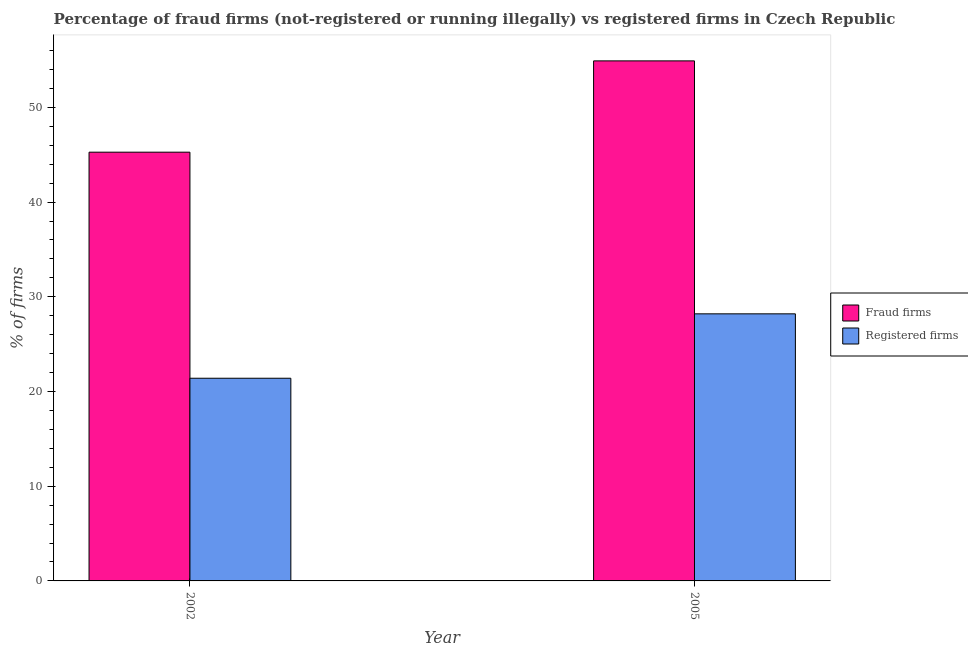How many different coloured bars are there?
Your answer should be very brief. 2. What is the label of the 2nd group of bars from the left?
Make the answer very short. 2005. In how many cases, is the number of bars for a given year not equal to the number of legend labels?
Make the answer very short. 0. What is the percentage of fraud firms in 2002?
Make the answer very short. 45.27. Across all years, what is the maximum percentage of fraud firms?
Provide a succinct answer. 54.91. Across all years, what is the minimum percentage of registered firms?
Your response must be concise. 21.4. What is the total percentage of registered firms in the graph?
Provide a succinct answer. 49.6. What is the difference between the percentage of registered firms in 2002 and that in 2005?
Make the answer very short. -6.8. What is the difference between the percentage of fraud firms in 2005 and the percentage of registered firms in 2002?
Make the answer very short. 9.64. What is the average percentage of fraud firms per year?
Give a very brief answer. 50.09. What is the ratio of the percentage of registered firms in 2002 to that in 2005?
Your response must be concise. 0.76. What does the 2nd bar from the left in 2002 represents?
Provide a succinct answer. Registered firms. What does the 1st bar from the right in 2002 represents?
Your answer should be very brief. Registered firms. How many bars are there?
Provide a succinct answer. 4. How many years are there in the graph?
Provide a short and direct response. 2. What is the difference between two consecutive major ticks on the Y-axis?
Offer a very short reply. 10. Are the values on the major ticks of Y-axis written in scientific E-notation?
Keep it short and to the point. No. Does the graph contain any zero values?
Keep it short and to the point. No. Where does the legend appear in the graph?
Your answer should be very brief. Center right. How many legend labels are there?
Ensure brevity in your answer.  2. How are the legend labels stacked?
Your answer should be compact. Vertical. What is the title of the graph?
Your answer should be compact. Percentage of fraud firms (not-registered or running illegally) vs registered firms in Czech Republic. Does "By country of asylum" appear as one of the legend labels in the graph?
Offer a very short reply. No. What is the label or title of the Y-axis?
Your answer should be very brief. % of firms. What is the % of firms of Fraud firms in 2002?
Your answer should be very brief. 45.27. What is the % of firms of Registered firms in 2002?
Offer a terse response. 21.4. What is the % of firms of Fraud firms in 2005?
Offer a terse response. 54.91. What is the % of firms in Registered firms in 2005?
Ensure brevity in your answer.  28.2. Across all years, what is the maximum % of firms of Fraud firms?
Ensure brevity in your answer.  54.91. Across all years, what is the maximum % of firms in Registered firms?
Provide a short and direct response. 28.2. Across all years, what is the minimum % of firms of Fraud firms?
Ensure brevity in your answer.  45.27. Across all years, what is the minimum % of firms of Registered firms?
Your answer should be very brief. 21.4. What is the total % of firms in Fraud firms in the graph?
Your answer should be very brief. 100.18. What is the total % of firms of Registered firms in the graph?
Keep it short and to the point. 49.6. What is the difference between the % of firms of Fraud firms in 2002 and that in 2005?
Make the answer very short. -9.64. What is the difference between the % of firms of Fraud firms in 2002 and the % of firms of Registered firms in 2005?
Provide a short and direct response. 17.07. What is the average % of firms of Fraud firms per year?
Your response must be concise. 50.09. What is the average % of firms in Registered firms per year?
Your response must be concise. 24.8. In the year 2002, what is the difference between the % of firms in Fraud firms and % of firms in Registered firms?
Keep it short and to the point. 23.87. In the year 2005, what is the difference between the % of firms in Fraud firms and % of firms in Registered firms?
Ensure brevity in your answer.  26.71. What is the ratio of the % of firms of Fraud firms in 2002 to that in 2005?
Keep it short and to the point. 0.82. What is the ratio of the % of firms in Registered firms in 2002 to that in 2005?
Your response must be concise. 0.76. What is the difference between the highest and the second highest % of firms of Fraud firms?
Provide a short and direct response. 9.64. What is the difference between the highest and the second highest % of firms in Registered firms?
Provide a succinct answer. 6.8. What is the difference between the highest and the lowest % of firms of Fraud firms?
Provide a short and direct response. 9.64. 